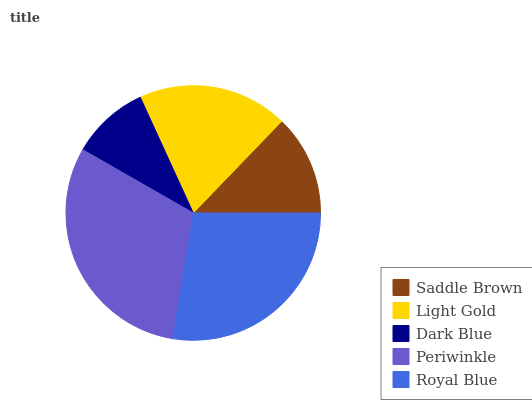Is Dark Blue the minimum?
Answer yes or no. Yes. Is Periwinkle the maximum?
Answer yes or no. Yes. Is Light Gold the minimum?
Answer yes or no. No. Is Light Gold the maximum?
Answer yes or no. No. Is Light Gold greater than Saddle Brown?
Answer yes or no. Yes. Is Saddle Brown less than Light Gold?
Answer yes or no. Yes. Is Saddle Brown greater than Light Gold?
Answer yes or no. No. Is Light Gold less than Saddle Brown?
Answer yes or no. No. Is Light Gold the high median?
Answer yes or no. Yes. Is Light Gold the low median?
Answer yes or no. Yes. Is Dark Blue the high median?
Answer yes or no. No. Is Royal Blue the low median?
Answer yes or no. No. 